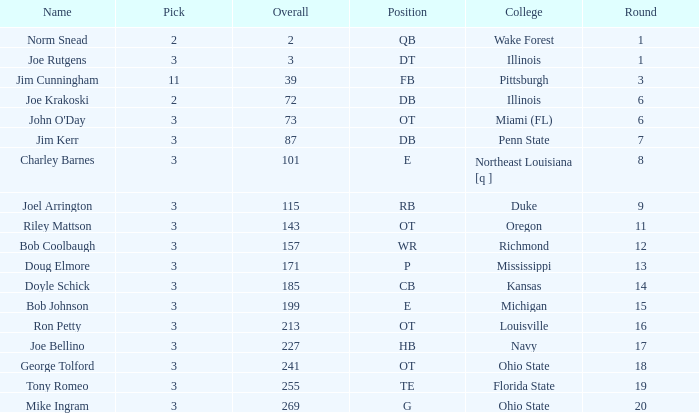How many overalls have charley barnes as the name, with a pick less than 3? None. 